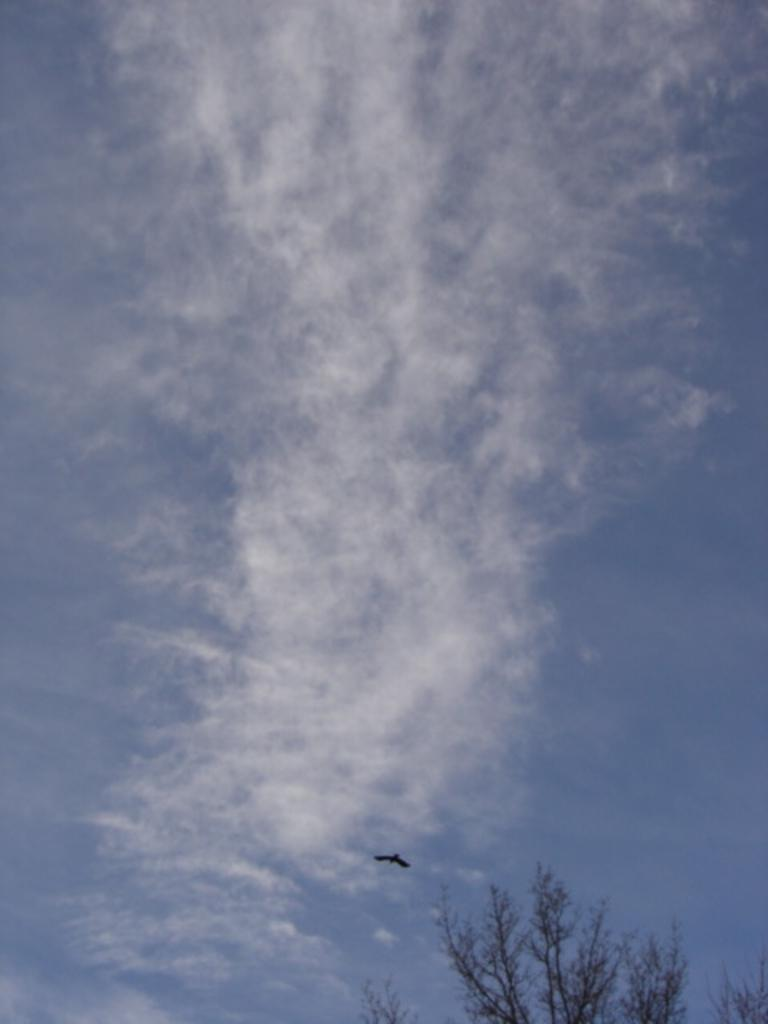What type of vegetation can be seen in the image? There are trees in the image. What is the bird in the image doing? The bird is flying in the image. What can be seen in the background of the image? The sky is visible in the background of the image. What is the condition of the sky in the image? Clouds are present in the sky. What is the name of the daughter in the image? There is no daughter present in the image. What shape is the bird in the image? The bird is not a shape; it is a living creature. 